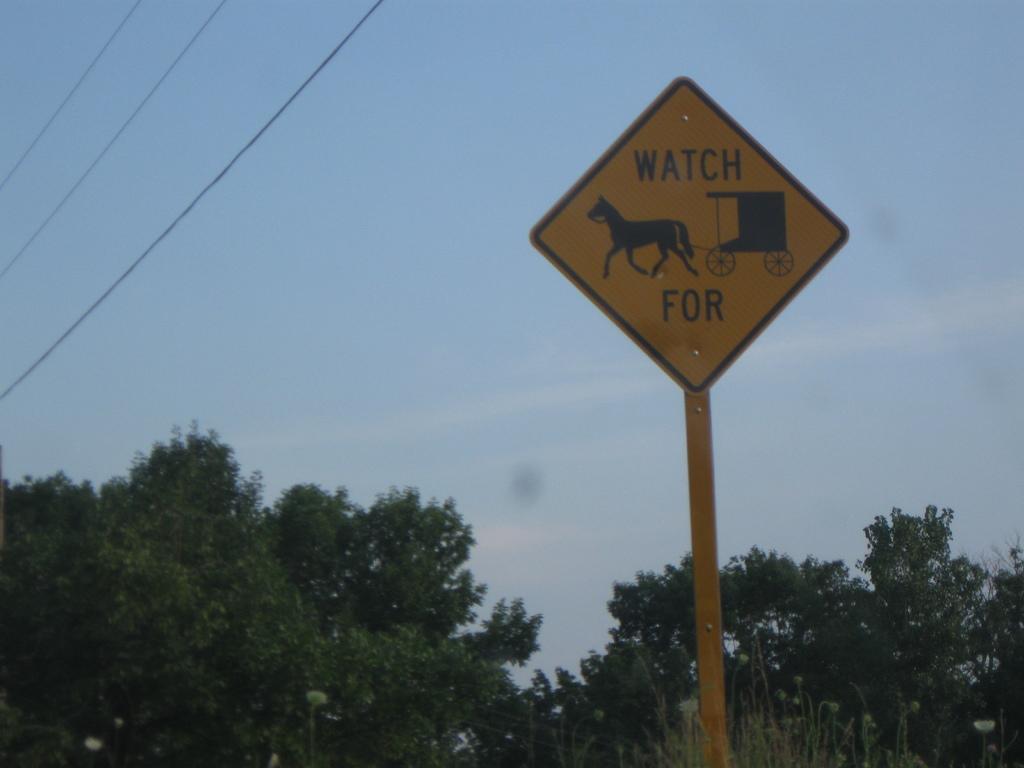Can you describe this image briefly? In this image I can see a pole with a sign board towards the right hand side of the image. At the bottom of the image I can see the trees. At the top of the image I can see the sky. In the top left corner I can see some wires. 